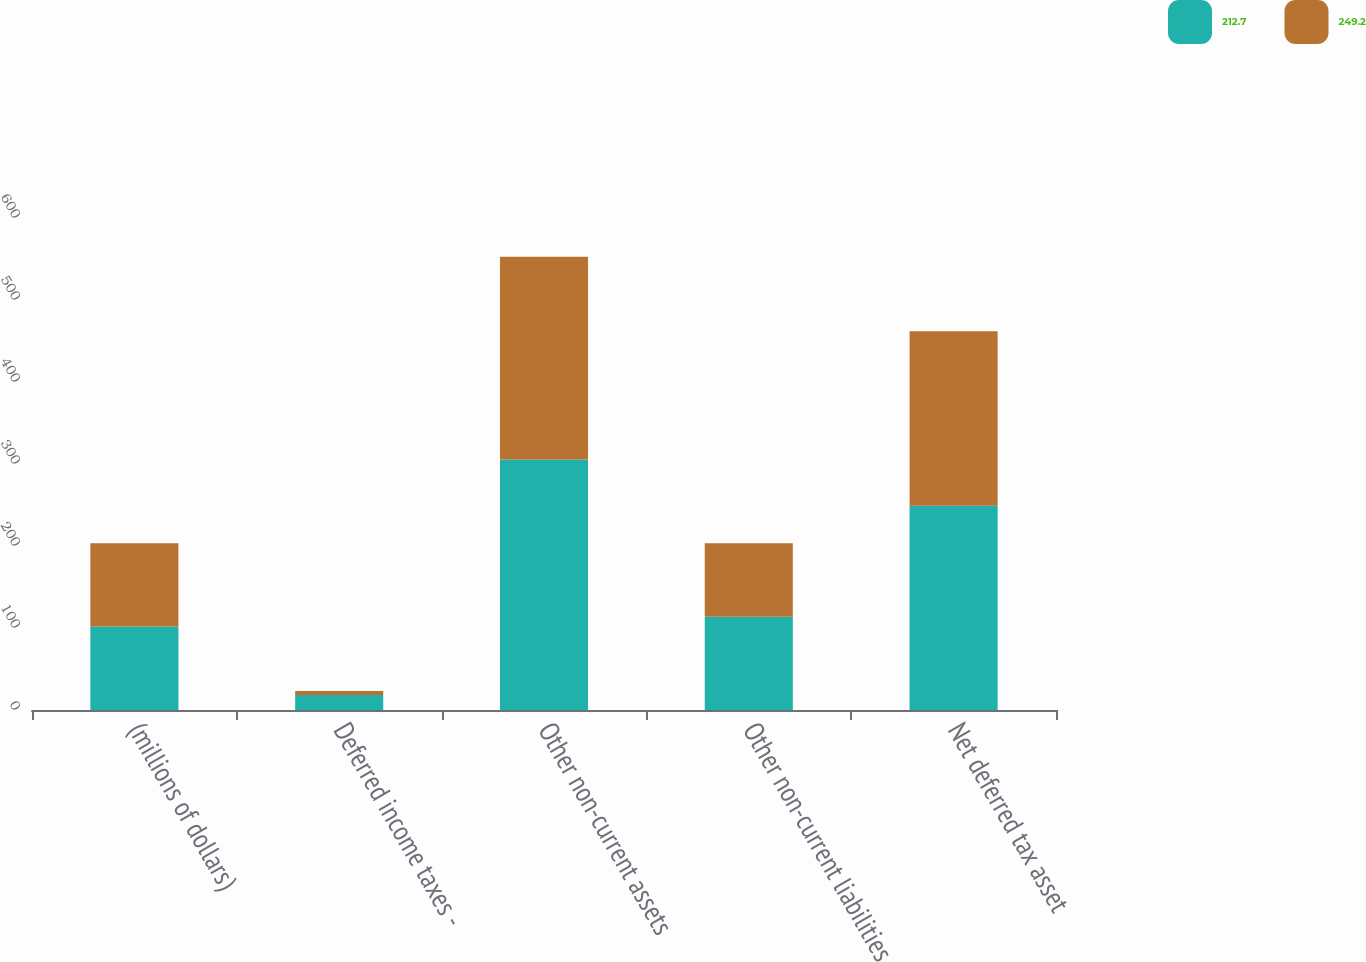Convert chart. <chart><loc_0><loc_0><loc_500><loc_500><stacked_bar_chart><ecel><fcel>(millions of dollars)<fcel>Deferred income taxes -<fcel>Other non-current assets<fcel>Other non-current liabilities<fcel>Net deferred tax asset<nl><fcel>212.7<fcel>101.75<fcel>18.4<fcel>305.5<fcel>113.7<fcel>249.2<nl><fcel>249.2<fcel>101.75<fcel>4.8<fcel>247.1<fcel>89.8<fcel>212.7<nl></chart> 